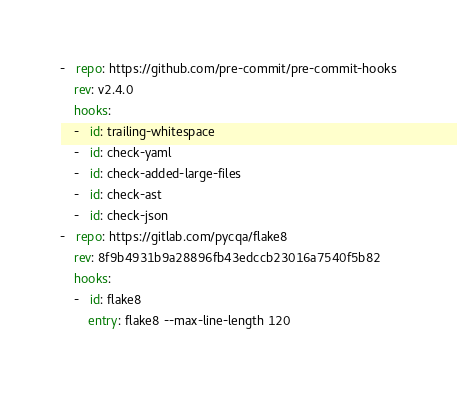<code> <loc_0><loc_0><loc_500><loc_500><_YAML_>-   repo: https://github.com/pre-commit/pre-commit-hooks
    rev: v2.4.0
    hooks:
    -   id: trailing-whitespace
    -   id: check-yaml
    -   id: check-added-large-files
    -   id: check-ast
    -   id: check-json
-   repo: https://gitlab.com/pycqa/flake8
    rev: 8f9b4931b9a28896fb43edccb23016a7540f5b82
    hooks:
    -   id: flake8
        entry: flake8 --max-line-length 120
</code> 